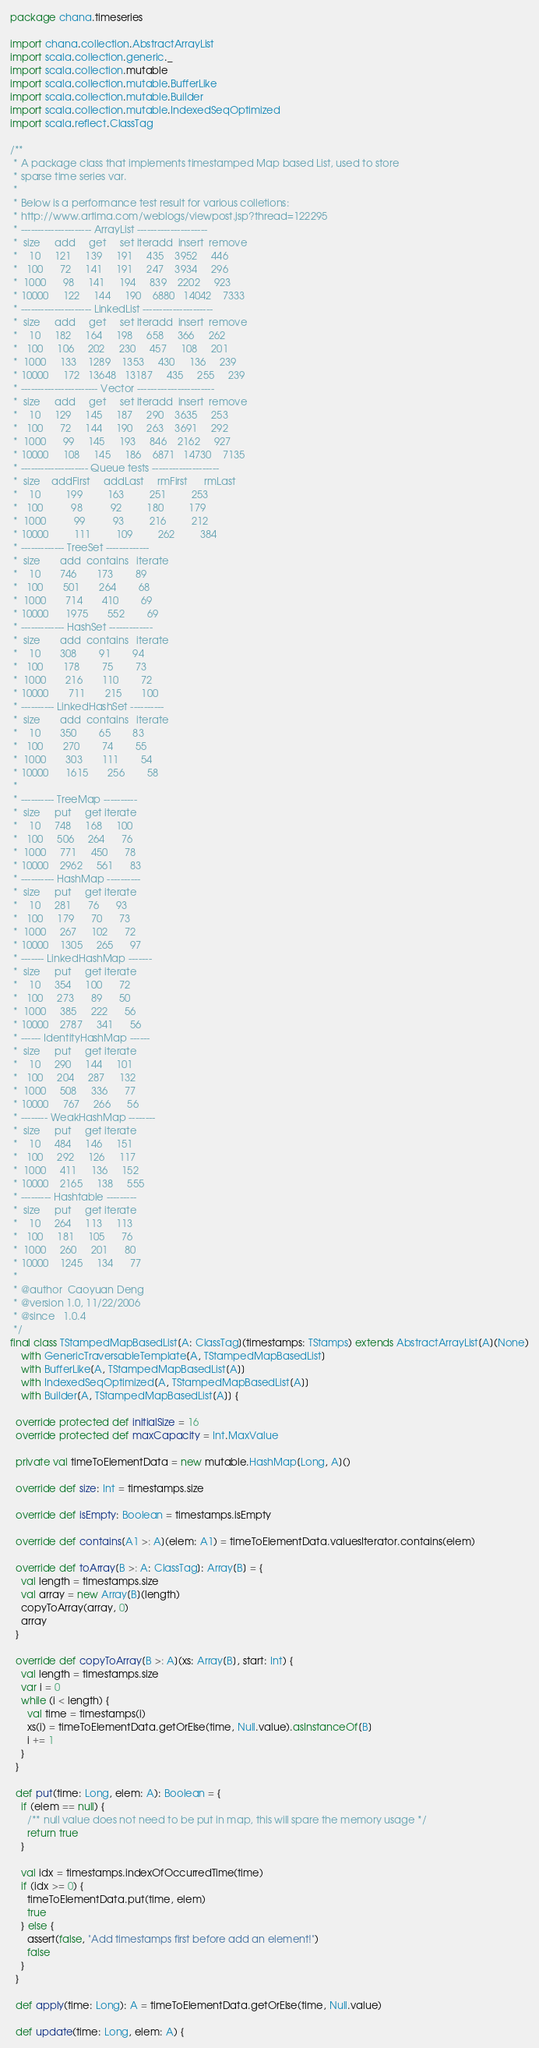<code> <loc_0><loc_0><loc_500><loc_500><_Scala_>package chana.timeseries

import chana.collection.AbstractArrayList
import scala.collection.generic._
import scala.collection.mutable
import scala.collection.mutable.BufferLike
import scala.collection.mutable.Builder
import scala.collection.mutable.IndexedSeqOptimized
import scala.reflect.ClassTag

/**
 * A package class that implements timestamped Map based List, used to store
 * sparse time series var.
 *
 * Below is a performance test result for various colletions:
 * http://www.artima.com/weblogs/viewpost.jsp?thread=122295
 * --------------------- ArrayList ---------------------
 *  size     add     get     set iteradd  insert  remove
 *    10     121     139     191     435    3952     446
 *   100      72     141     191     247    3934     296
 *  1000      98     141     194     839    2202     923
 * 10000     122     144     190    6880   14042    7333
 * --------------------- LinkedList ---------------------
 *  size     add     get     set iteradd  insert  remove
 *    10     182     164     198     658     366     262
 *   100     106     202     230     457     108     201
 *  1000     133    1289    1353     430     136     239
 * 10000     172   13648   13187     435     255     239
 * ----------------------- Vector -----------------------
 *  size     add     get     set iteradd  insert  remove
 *    10     129     145     187     290    3635     253
 *   100      72     144     190     263    3691     292
 *  1000      99     145     193     846    2162     927
 * 10000     108     145     186    6871   14730    7135
 * -------------------- Queue tests --------------------
 *  size    addFirst     addLast     rmFirst      rmLast
 *    10         199         163         251         253
 *   100          98          92         180         179
 *  1000          99          93         216         212
 * 10000         111         109         262         384
 * ------------- TreeSet -------------
 *  size       add  contains   iterate
 *    10       746       173        89
 *   100       501       264        68
 *  1000       714       410        69
 * 10000      1975       552        69
 * ------------- HashSet -------------
 *  size       add  contains   iterate
 *    10       308        91        94
 *   100       178        75        73
 *  1000       216       110        72
 * 10000       711       215       100
 * ---------- LinkedHashSet ----------
 *  size       add  contains   iterate
 *    10       350        65        83
 *   100       270        74        55
 *  1000       303       111        54
 * 10000      1615       256        58
 *
 * ---------- TreeMap ----------
 *  size     put     get iterate
 *    10     748     168     100
 *   100     506     264      76
 *  1000     771     450      78
 * 10000    2962     561      83
 * ---------- HashMap ----------
 *  size     put     get iterate
 *    10     281      76      93
 *   100     179      70      73
 *  1000     267     102      72
 * 10000    1305     265      97
 * ------- LinkedHashMap -------
 *  size     put     get iterate
 *    10     354     100      72
 *   100     273      89      50
 *  1000     385     222      56
 * 10000    2787     341      56
 * ------ IdentityHashMap ------
 *  size     put     get iterate
 *    10     290     144     101
 *   100     204     287     132
 *  1000     508     336      77
 * 10000     767     266      56
 * -------- WeakHashMap --------
 *  size     put     get iterate
 *    10     484     146     151
 *   100     292     126     117
 *  1000     411     136     152
 * 10000    2165     138     555
 * --------- Hashtable ---------
 *  size     put     get iterate
 *    10     264     113     113
 *   100     181     105      76
 *  1000     260     201      80
 * 10000    1245     134      77
 *
 * @author  Caoyuan Deng
 * @version 1.0, 11/22/2006
 * @since   1.0.4
 */
final class TStampedMapBasedList[A: ClassTag](timestamps: TStamps) extends AbstractArrayList[A](None)
    with GenericTraversableTemplate[A, TStampedMapBasedList]
    with BufferLike[A, TStampedMapBasedList[A]]
    with IndexedSeqOptimized[A, TStampedMapBasedList[A]]
    with Builder[A, TStampedMapBasedList[A]] {

  override protected def initialSize = 16
  override protected def maxCapacity = Int.MaxValue

  private val timeToElementData = new mutable.HashMap[Long, A]()

  override def size: Int = timestamps.size

  override def isEmpty: Boolean = timestamps.isEmpty

  override def contains[A1 >: A](elem: A1) = timeToElementData.valuesIterator.contains(elem)

  override def toArray[B >: A: ClassTag]: Array[B] = {
    val length = timestamps.size
    val array = new Array[B](length)
    copyToArray(array, 0)
    array
  }

  override def copyToArray[B >: A](xs: Array[B], start: Int) {
    val length = timestamps.size
    var i = 0
    while (i < length) {
      val time = timestamps(i)
      xs(i) = timeToElementData.getOrElse(time, Null.value).asInstanceOf[B]
      i += 1
    }
  }

  def put(time: Long, elem: A): Boolean = {
    if (elem == null) {
      /** null value does not need to be put in map, this will spare the memory usage */
      return true
    }

    val idx = timestamps.indexOfOccurredTime(time)
    if (idx >= 0) {
      timeToElementData.put(time, elem)
      true
    } else {
      assert(false, "Add timestamps first before add an element!")
      false
    }
  }

  def apply(time: Long): A = timeToElementData.getOrElse(time, Null.value)

  def update(time: Long, elem: A) {</code> 